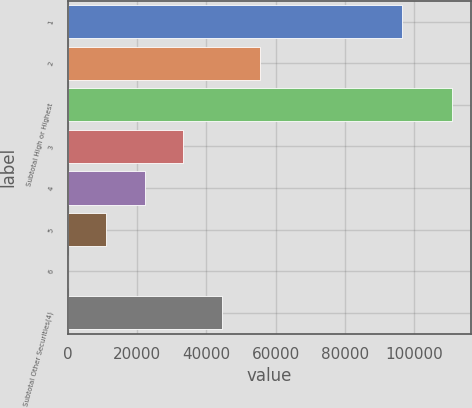Convert chart. <chart><loc_0><loc_0><loc_500><loc_500><bar_chart><fcel>1<fcel>2<fcel>Subtotal High or Highest<fcel>3<fcel>4<fcel>5<fcel>6<fcel>Subtotal Other Securities(4)<nl><fcel>96290<fcel>55517<fcel>110881<fcel>33371.4<fcel>22298.6<fcel>11225.8<fcel>153<fcel>44444.2<nl></chart> 